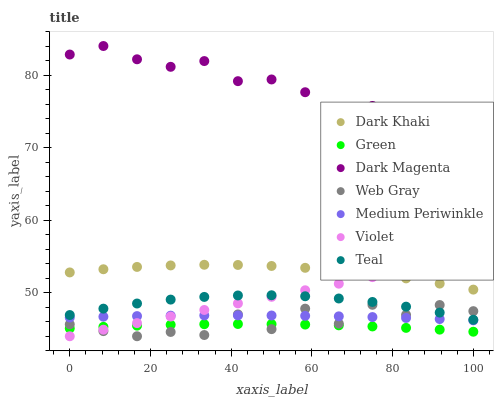Does Green have the minimum area under the curve?
Answer yes or no. Yes. Does Dark Magenta have the maximum area under the curve?
Answer yes or no. Yes. Does Medium Periwinkle have the minimum area under the curve?
Answer yes or no. No. Does Medium Periwinkle have the maximum area under the curve?
Answer yes or no. No. Is Violet the smoothest?
Answer yes or no. Yes. Is Web Gray the roughest?
Answer yes or no. Yes. Is Dark Magenta the smoothest?
Answer yes or no. No. Is Dark Magenta the roughest?
Answer yes or no. No. Does Web Gray have the lowest value?
Answer yes or no. Yes. Does Medium Periwinkle have the lowest value?
Answer yes or no. No. Does Dark Magenta have the highest value?
Answer yes or no. Yes. Does Medium Periwinkle have the highest value?
Answer yes or no. No. Is Green less than Teal?
Answer yes or no. Yes. Is Dark Magenta greater than Dark Khaki?
Answer yes or no. Yes. Does Web Gray intersect Teal?
Answer yes or no. Yes. Is Web Gray less than Teal?
Answer yes or no. No. Is Web Gray greater than Teal?
Answer yes or no. No. Does Green intersect Teal?
Answer yes or no. No. 